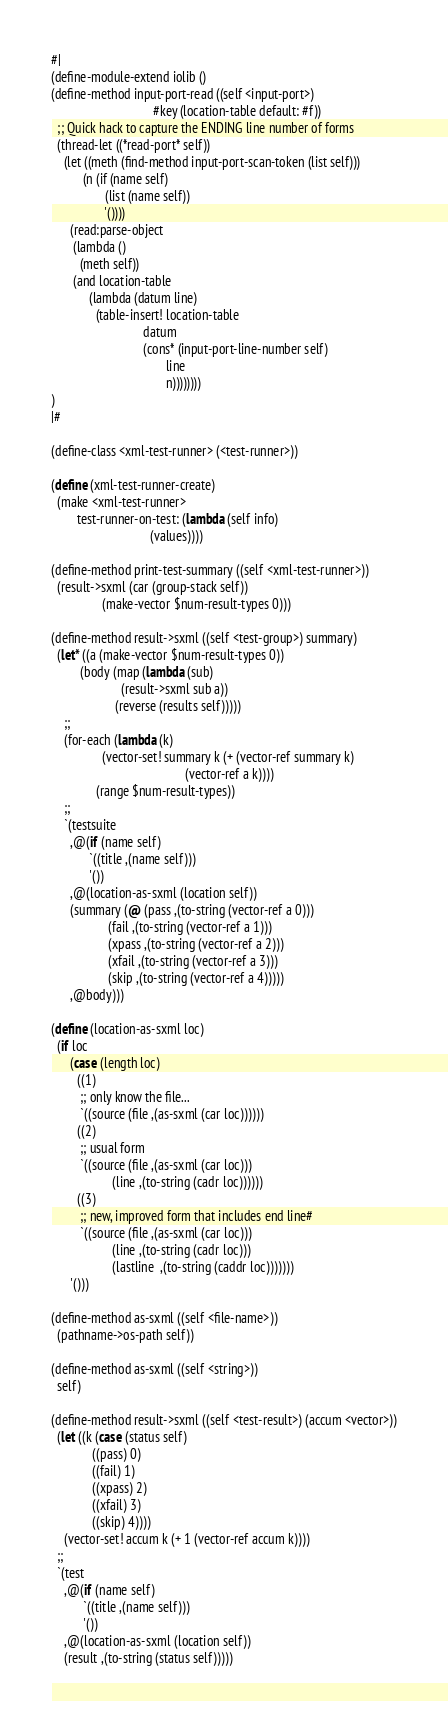<code> <loc_0><loc_0><loc_500><loc_500><_Scheme_>#|
(define-module-extend iolib ()
(define-method input-port-read ((self <input-port>) 
                                #key (location-table default: #f))
  ;; Quick hack to capture the ENDING line number of forms
  (thread-let ((*read-port* self))
    (let ((meth (find-method input-port-scan-token (list self)))
          (n (if (name self)
                 (list (name self))
                 '())))
      (read:parse-object 
       (lambda ()
         (meth self))
       (and location-table
            (lambda (datum line)
              (table-insert! location-table 
                             datum
                             (cons* (input-port-line-number self) 
                                    line
                                    n))))))))
)
|#

(define-class <xml-test-runner> (<test-runner>))

(define (xml-test-runner-create)
  (make <xml-test-runner>
        test-runner-on-test: (lambda (self info)
                               (values))))

(define-method print-test-summary ((self <xml-test-runner>))
  (result->sxml (car (group-stack self)) 
                (make-vector $num-result-types 0)))

(define-method result->sxml ((self <test-group>) summary)
  (let* ((a (make-vector $num-result-types 0))
         (body (map (lambda (sub)
                      (result->sxml sub a))
                    (reverse (results self)))))
    ;;
    (for-each (lambda (k)
                (vector-set! summary k (+ (vector-ref summary k)
                                          (vector-ref a k))))
              (range $num-result-types))
    ;;
    `(testsuite
      ,@(if (name self)
            `((title ,(name self)))
            '())
      ,@(location-as-sxml (location self))
      (summary (@ (pass ,(to-string (vector-ref a 0)))
                  (fail ,(to-string (vector-ref a 1)))
                  (xpass ,(to-string (vector-ref a 2)))
                  (xfail ,(to-string (vector-ref a 3)))
                  (skip ,(to-string (vector-ref a 4)))))
      ,@body)))

(define (location-as-sxml loc)
  (if loc
      (case (length loc)
        ((1)
         ;; only know the file...
         `((source (file ,(as-sxml (car loc))))))
        ((2)
         ;; usual form
         `((source (file ,(as-sxml (car loc)))
                   (line ,(to-string (cadr loc))))))
        ((3)
         ;; new, improved form that includes end line#
         `((source (file ,(as-sxml (car loc)))
                   (line ,(to-string (cadr loc)))
                   (lastline  ,(to-string (caddr loc)))))))
      '()))

(define-method as-sxml ((self <file-name>))
  (pathname->os-path self))

(define-method as-sxml ((self <string>))
  self)

(define-method result->sxml ((self <test-result>) (accum <vector>))
  (let ((k (case (status self)
             ((pass) 0)
             ((fail) 1)
             ((xpass) 2)
             ((xfail) 3)
             ((skip) 4))))
    (vector-set! accum k (+ 1 (vector-ref accum k))))
  ;;
  `(test
    ,@(if (name self)
          `((title ,(name self))) 
          '())
    ,@(location-as-sxml (location self))
    (result ,(to-string (status self)))))

</code> 